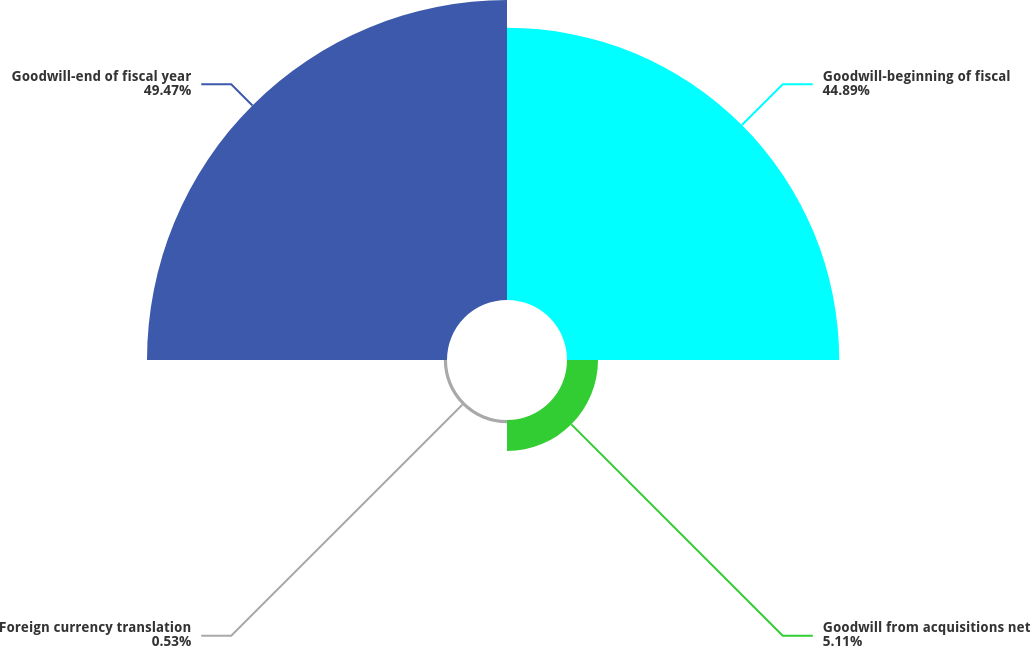Convert chart. <chart><loc_0><loc_0><loc_500><loc_500><pie_chart><fcel>Goodwill-beginning of fiscal<fcel>Goodwill from acquisitions net<fcel>Foreign currency translation<fcel>Goodwill-end of fiscal year<nl><fcel>44.89%<fcel>5.11%<fcel>0.53%<fcel>49.47%<nl></chart> 